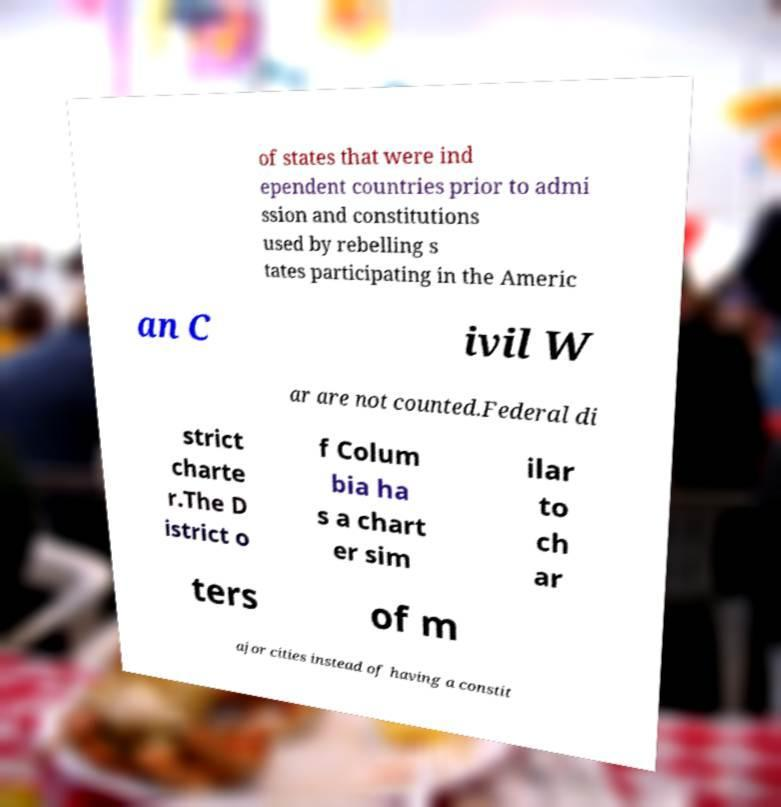Can you accurately transcribe the text from the provided image for me? of states that were ind ependent countries prior to admi ssion and constitutions used by rebelling s tates participating in the Americ an C ivil W ar are not counted.Federal di strict charte r.The D istrict o f Colum bia ha s a chart er sim ilar to ch ar ters of m ajor cities instead of having a constit 